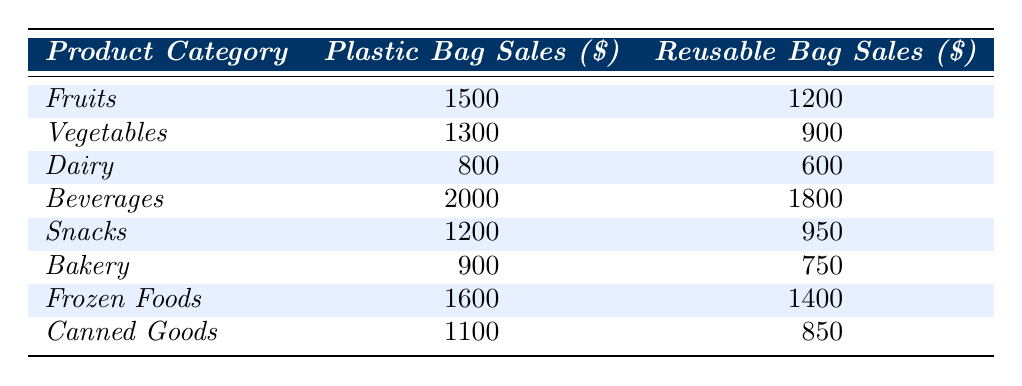What is the plastic bag sales for the Dairy category? The plastic bag sales for the Dairy category is specified in the table. It shows a value of 800.
Answer: 800 Which product category has the highest reusable bag sales? The table lists the reusable bag sales for each category. The highest value is for Beverages at 1800.
Answer: Beverages What is the difference in sales between plastic and reusable bags for Vegetables? From the table, plastic bag sales for Vegetables are 1300 and reusable are 900. The difference is calculated as 1300 - 900 = 400.
Answer: 400 What is the total plastic bag sales across all categories? To find the total plastic bag sales, add all the values from the plastic bag sales column. Calculating: 1500 + 1300 + 800 + 2000 + 1200 + 900 + 1600 + 1100 = 10300.
Answer: 10300 Is the reusable bag sales for Frozen Foods higher than that for Canned Goods? According to the table, Frozen Foods has reusable bag sales of 1400 while Canned Goods has 850. Therefore, 1400 is higher than 850.
Answer: Yes What is the average sales for plastic bags across all product categories? The sum of plastic bag sales is 1500 + 1300 + 800 + 2000 + 1200 + 900 + 1600 + 1100 = 10300. There are 8 categories, so the average is 10300 / 8 = 1287.5.
Answer: 1287.5 Which product category has the lowest sales for reusable bags? The lowest reusable bag sales are displayed in the Dairy category with a value of 600, compared to others.
Answer: Dairy How much more was earned from plastic bag sales than from reusable bag sales in the Snacks category? Referring to the table, plastic sales for Snacks is 1200 and reusable sales is 950. The difference is 1200 - 950 = 250.
Answer: 250 Which category saw a decrease in sales when switching from plastic to reusable bags? Compare sales for each category: Dairy (800 vs 600), Vegetables (1300 vs 900), Snacks (1200 vs 950), and so on show that all categories experienced a decrease except Beverages.
Answer: All categories except Beverages What percentage of the total sales for fruits came from reusable bags? Total sales for fruits is 1500 + 1200 = 2700. Reusable sales are 1200. The percentage is (1200 / 2700) * 100 = 44.44%.
Answer: 44.44% 